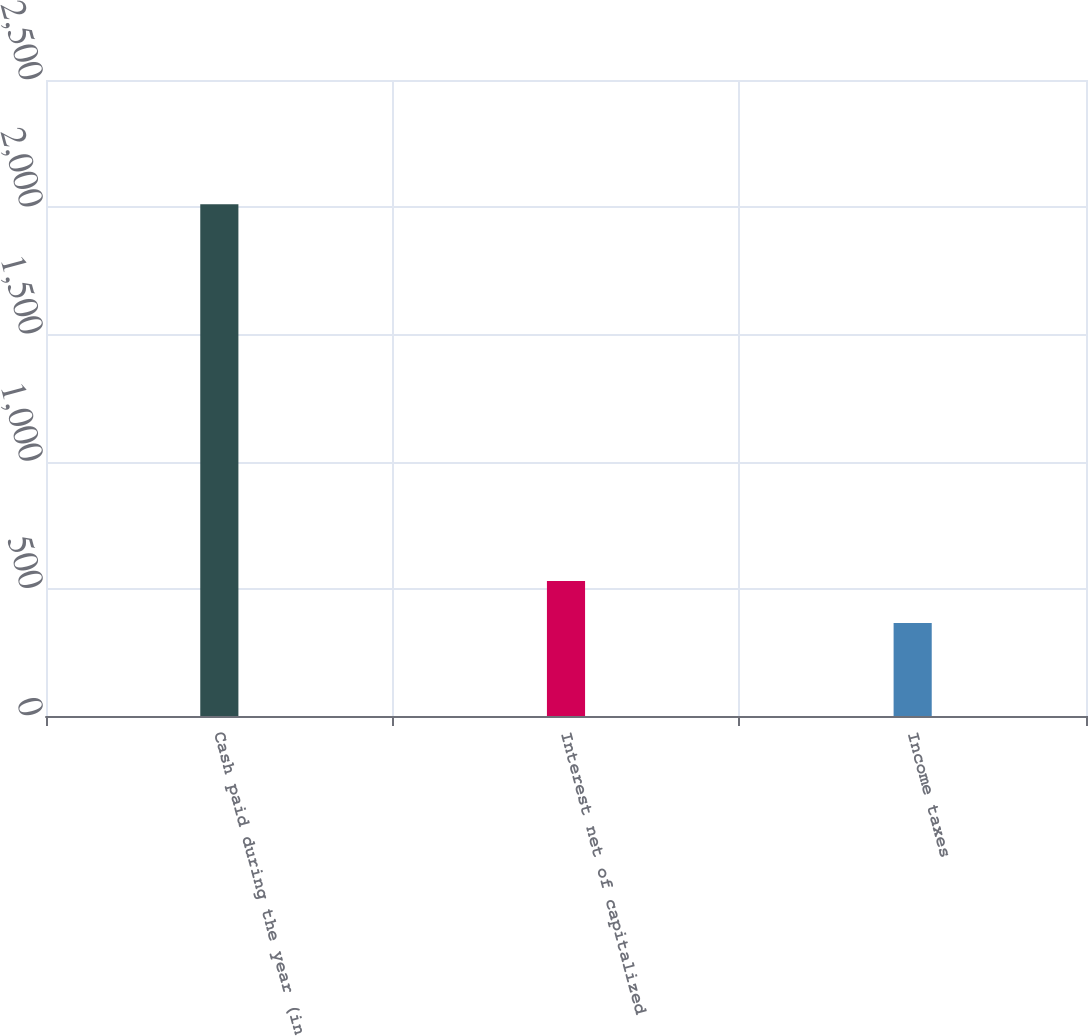<chart> <loc_0><loc_0><loc_500><loc_500><bar_chart><fcel>Cash paid during the year (in<fcel>Interest net of capitalized<fcel>Income taxes<nl><fcel>2012<fcel>530.6<fcel>366<nl></chart> 